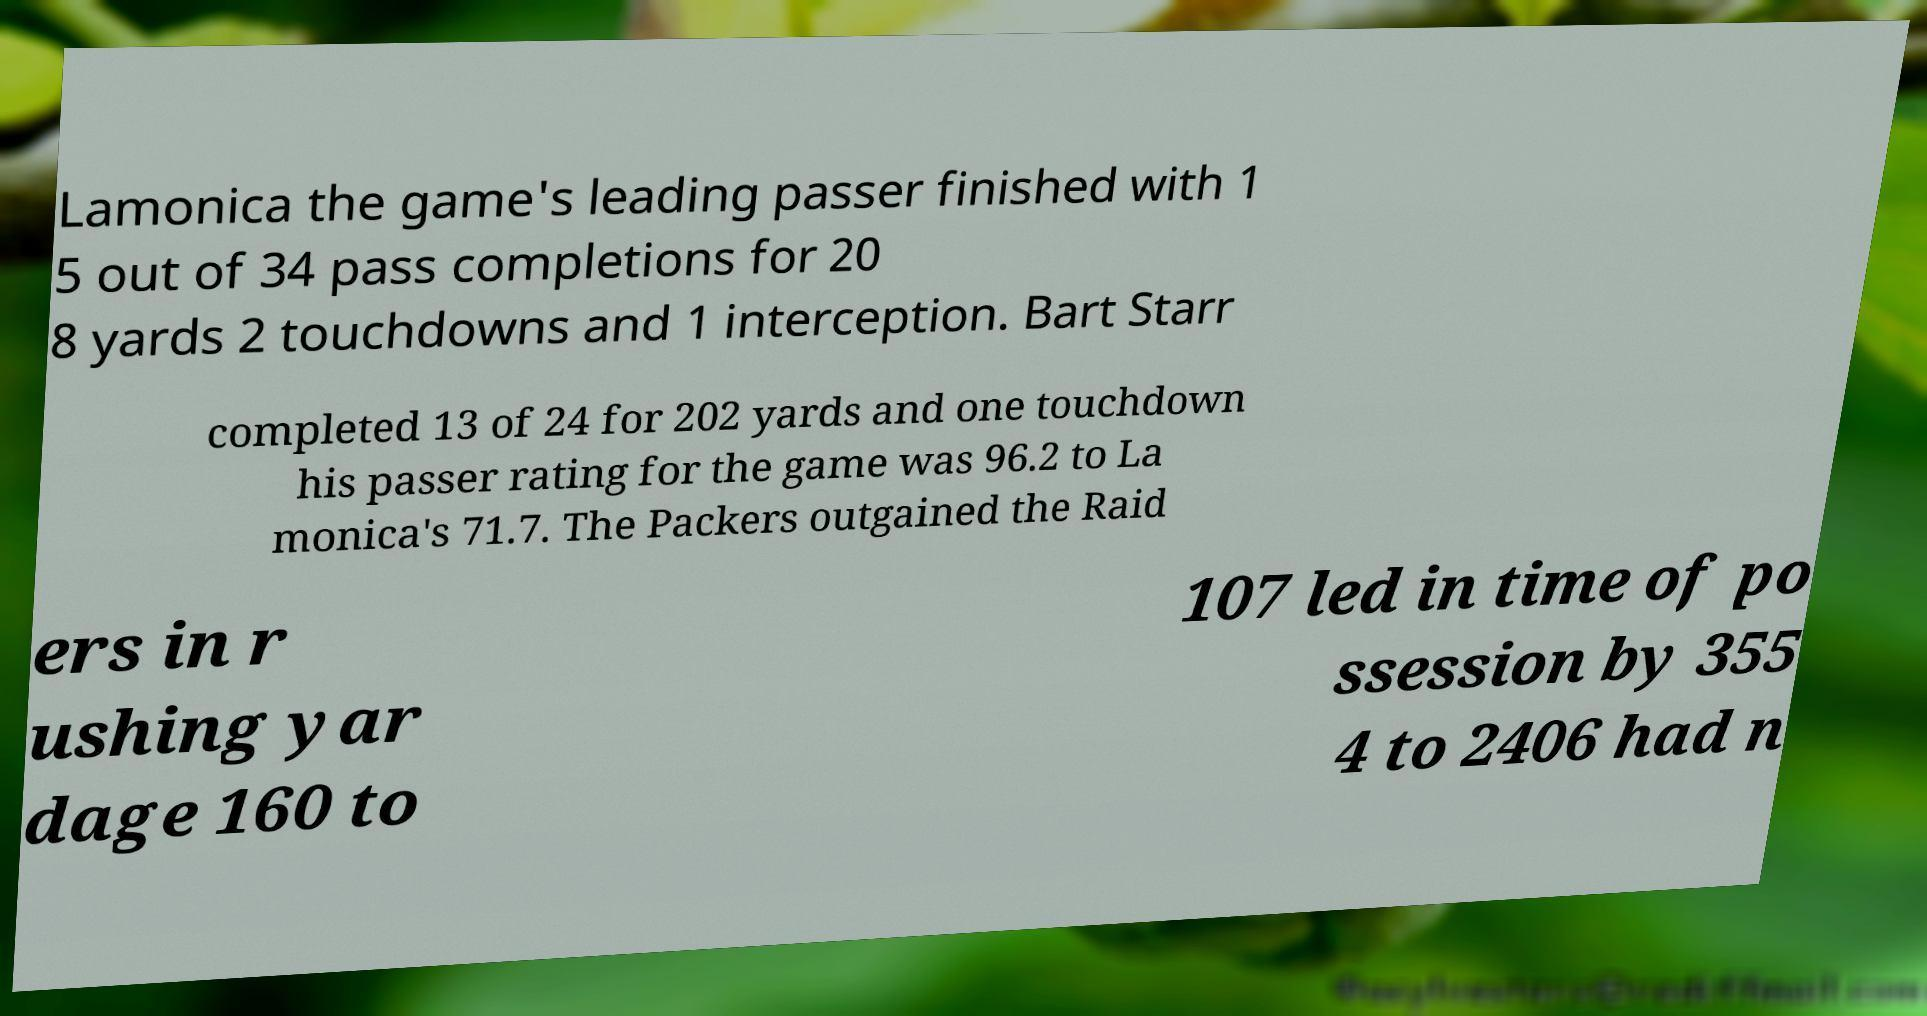Can you accurately transcribe the text from the provided image for me? Lamonica the game's leading passer finished with 1 5 out of 34 pass completions for 20 8 yards 2 touchdowns and 1 interception. Bart Starr completed 13 of 24 for 202 yards and one touchdown his passer rating for the game was 96.2 to La monica's 71.7. The Packers outgained the Raid ers in r ushing yar dage 160 to 107 led in time of po ssession by 355 4 to 2406 had n 